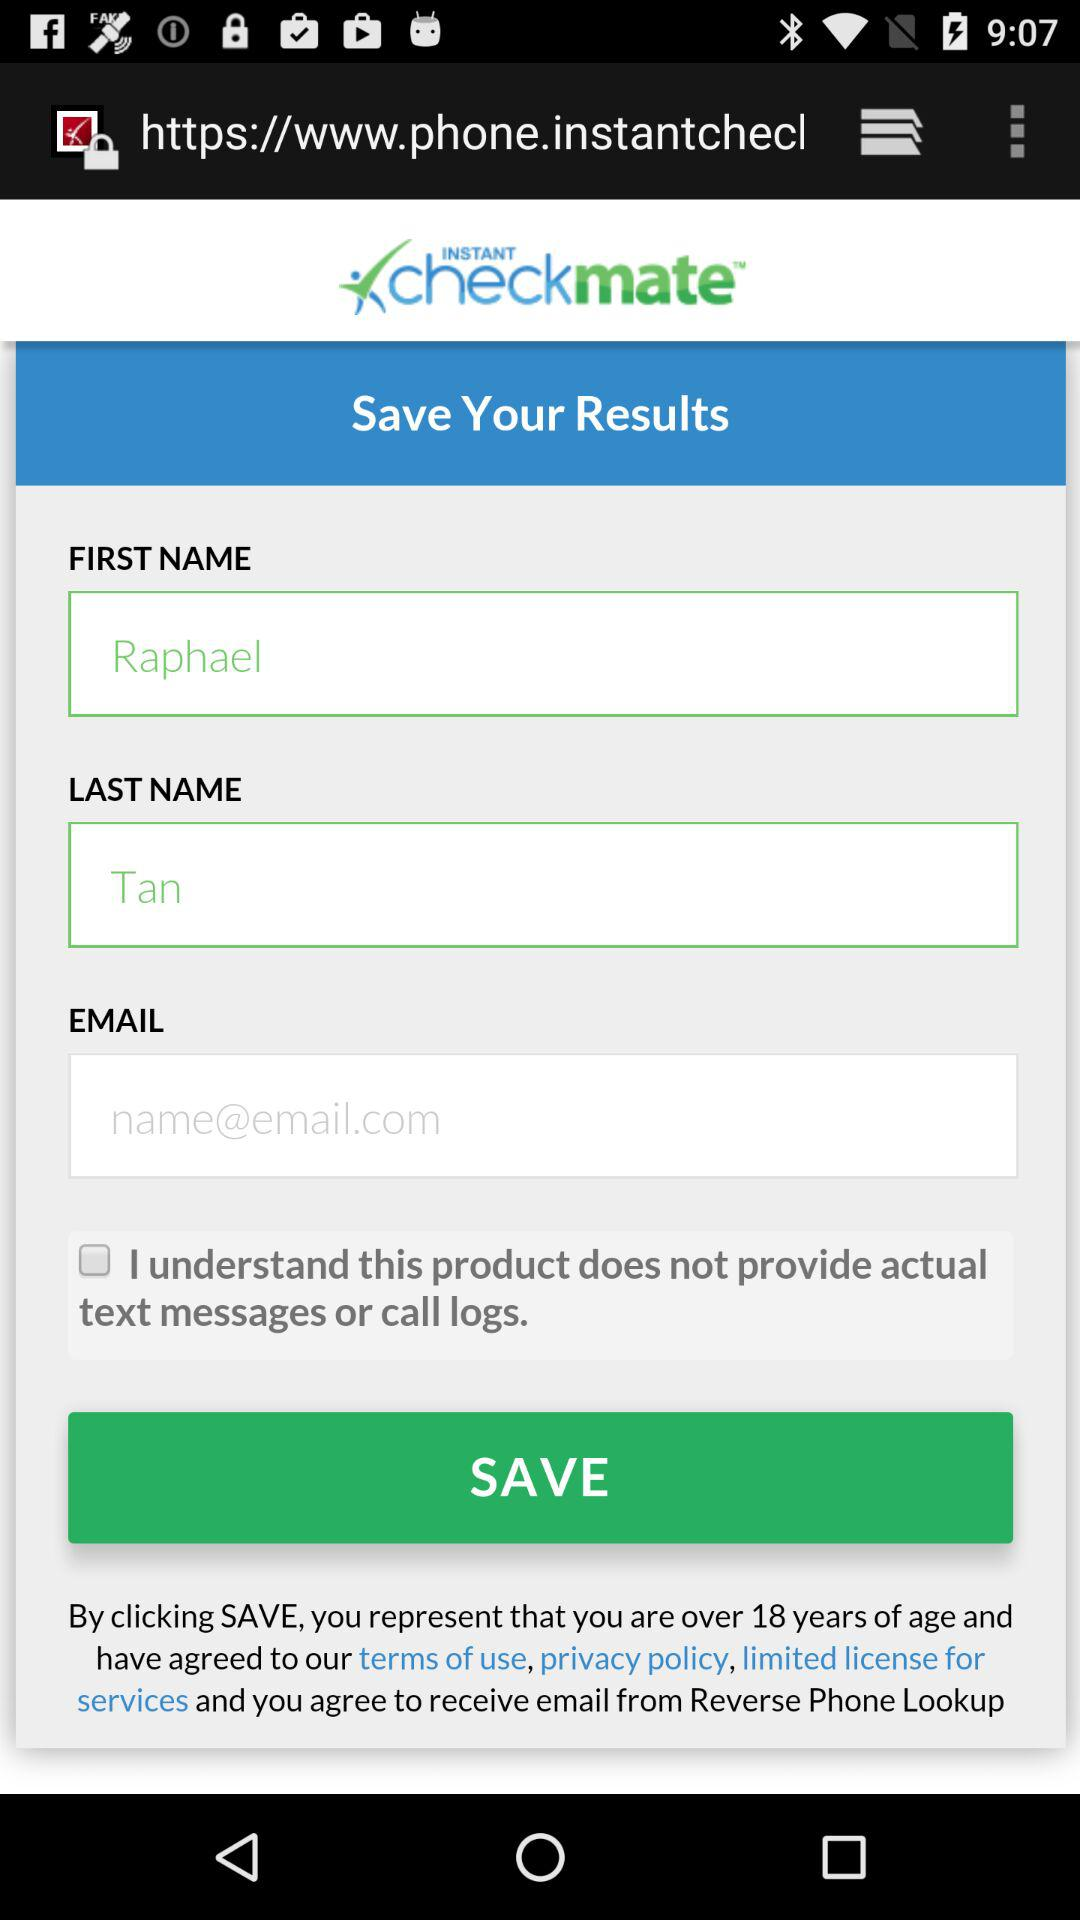What is the first name? The first name is Raphael. 